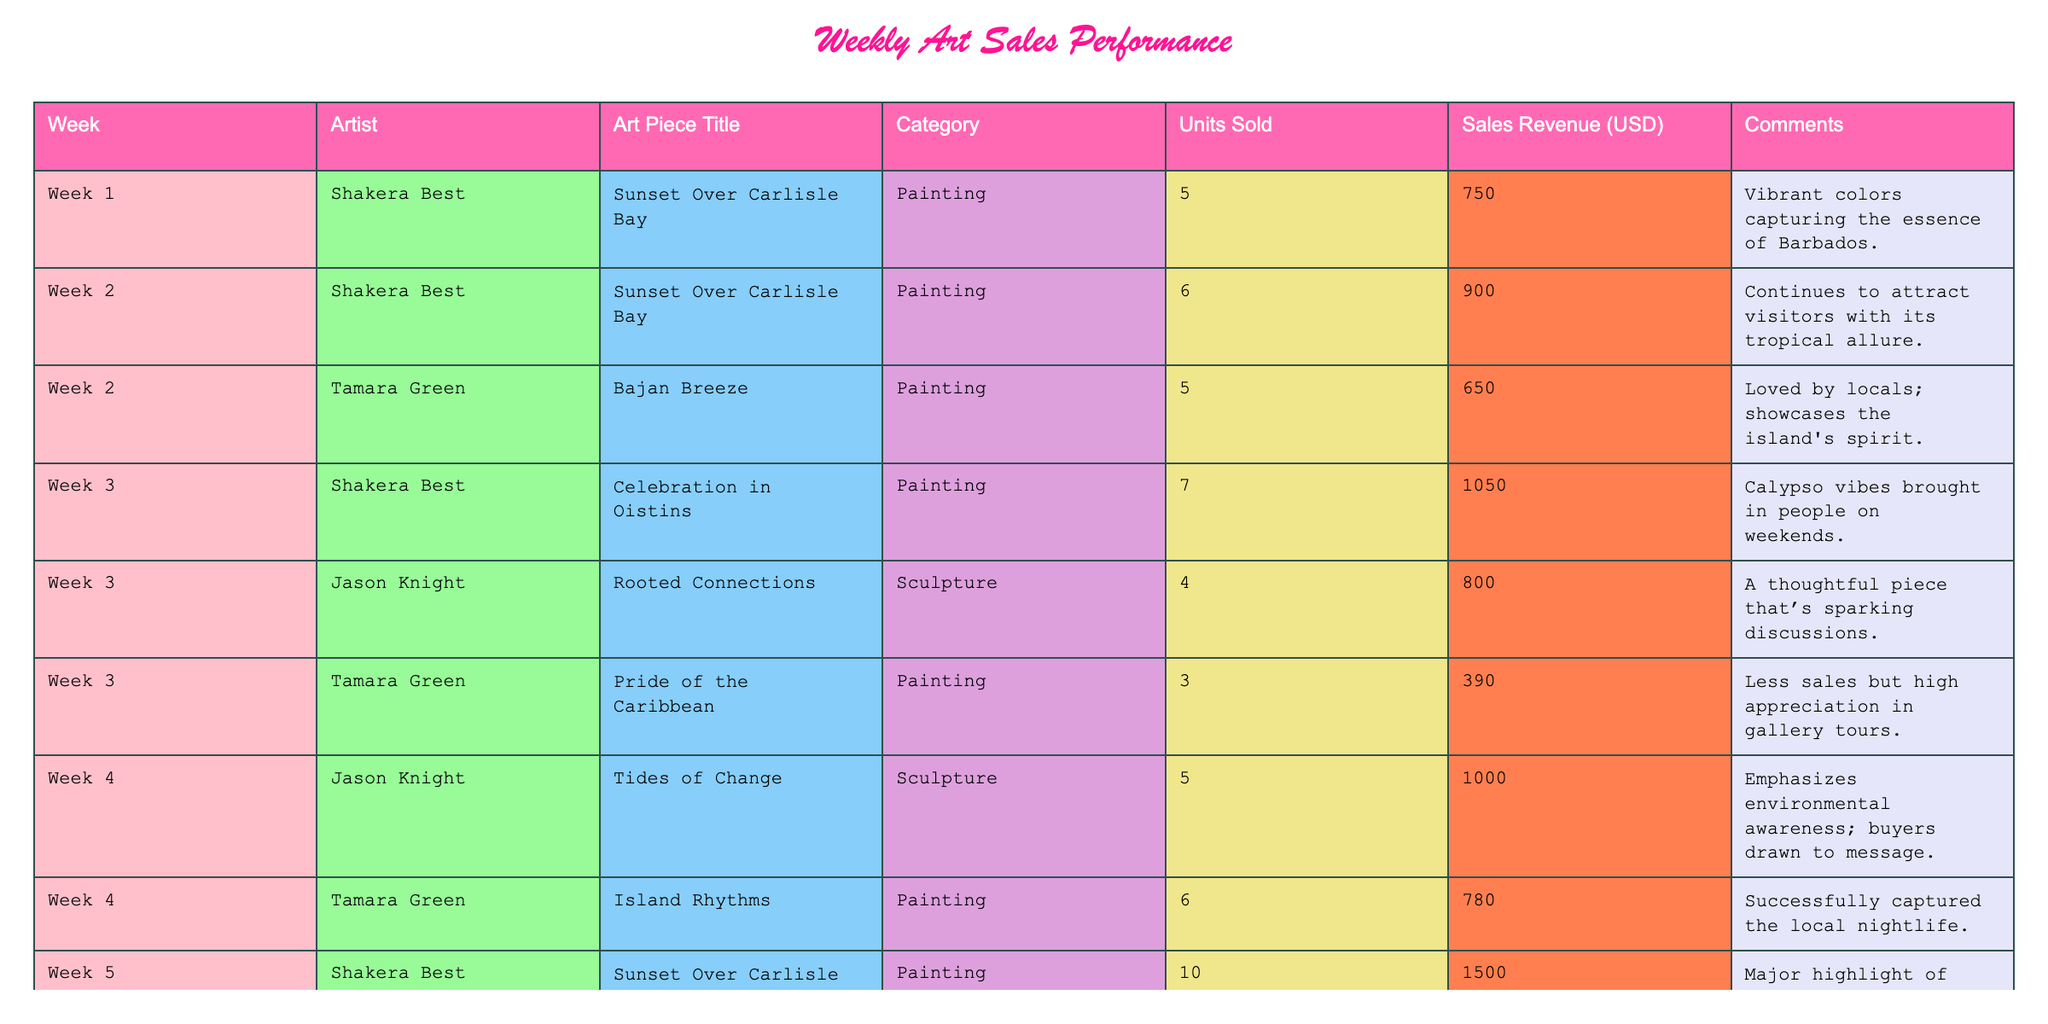What's the total number of units sold by Shakera Best? To find the total units sold by Shakera Best, we look at all the rows related to her. She sold 5, 6, 7, and 10 units across different weeks. Adding these together gives us 5 + 6 + 7 + 10 = 28 units sold.
Answer: 28 What was the week with the highest sales revenue, and how much was it? From the table, we identify the sales revenue for each week. During week 5, Shakera Best's piece generated 1500 USD, which is the highest revenue in the table. Thus, week 5 had the highest sales revenue.
Answer: Week 5, 1500 USD Did Tamara Green have more units sold than Jason Knight overall? We tally the units sold by Tamara Green (5 + 3 + 6 = 14) and Jason Knight (4 + 5 + 3 = 12). Since 14 is greater than 12, Tamara Green sold more units than Jason Knight overall.
Answer: Yes What is the average sales revenue for all painting pieces? We identify the sales revenue for all painting pieces: 750, 900, 1050, 650, 390, 780, and 1500. Adding these gives a total of 5220 USD. There are 7 painting pieces, so we divide 5220 by 7, yielding an average of approximately 746. Therefore, the average sales revenue for all painting pieces is around 746 USD.
Answer: 746 USD Which artist had the lowest individual sales revenue, and what was the amount? Looking at the sales revenue in the table, Tamara Green’s piece "Pride of the Caribbean" made only 390 USD, which is the lowest among all entries. Thus, she had the lowest individual sales revenue.
Answer: Tamara Green, 390 USD What category of art had the highest average sales revenue? We calculate the average sales revenue for each category: Paintings = (750 + 900 + 1050 + 650 + 390 + 780 + 1500)/7 = 746. Sculptures = (800 + 1000 + 600)/3 = 800. Comparing both averages, Sculptures have 800 USD, higher than Paintings at 746 USD. Hence, Sculptures had the highest average sales revenue.
Answer: Sculptures Which week saw the most diverse range of art pieces sold? In week 3, both paintings (by Shakera Best and Tamara Green) and a sculpture (Jason Knight) were sold, totaling three distinct pieces. This is the most diverse compared to other weeks. Weeks vary from one to three types, but week 3 stands out for having three.
Answer: Week 3 Was there a week where Jason Knight registered no sales? By reviewing Jason Knight's entries, he sold art pieces in weeks 3 and 4 but had no sales record in weeks 1, 2, and 5. Therefore, he had no sales in several weeks, confirming the answer as true for at least those weeks.
Answer: Yes 